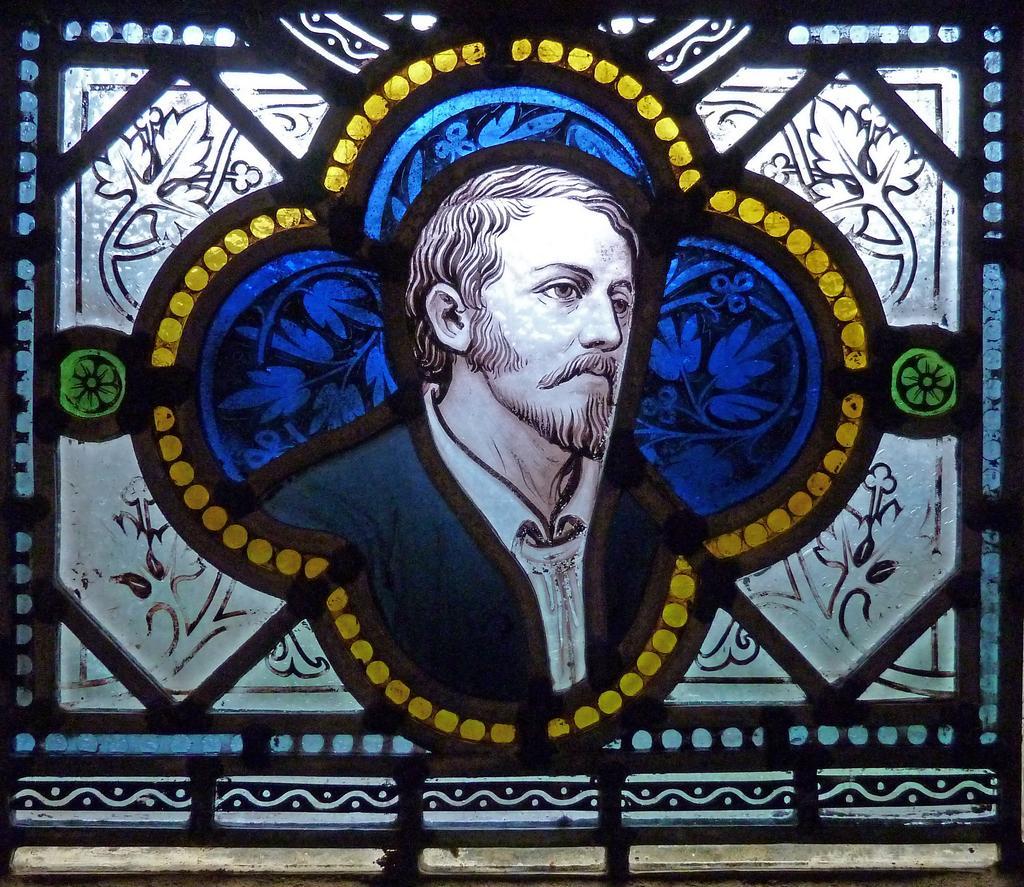Can you describe this image briefly? In this picture I can see a person in a frame. 